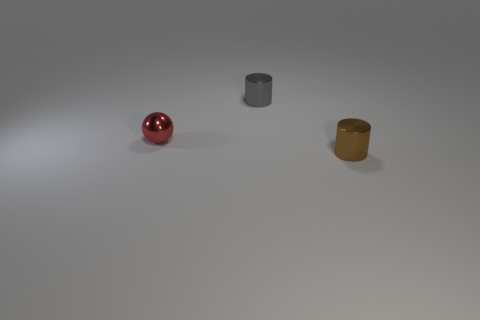Add 2 small gray metal cylinders. How many objects exist? 5 Subtract all cylinders. How many objects are left? 1 Subtract all tiny gray cylinders. Subtract all small gray things. How many objects are left? 1 Add 3 brown cylinders. How many brown cylinders are left? 4 Add 2 small gray objects. How many small gray objects exist? 3 Subtract 1 red balls. How many objects are left? 2 